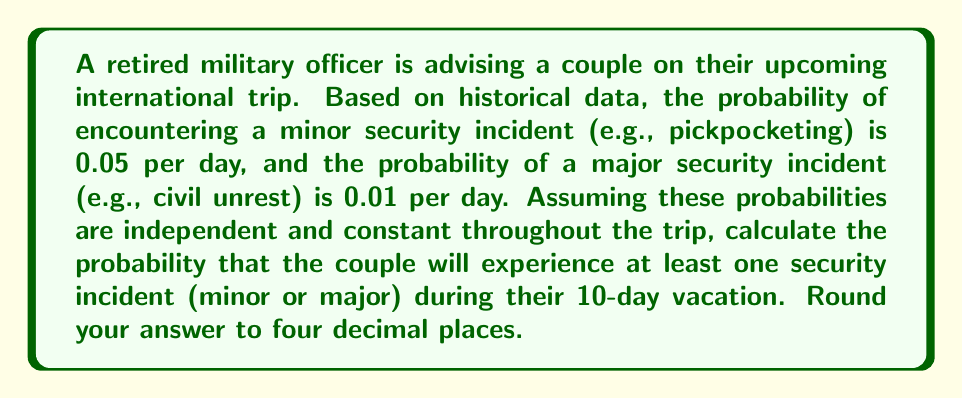Show me your answer to this math problem. Let's approach this step-by-step using probability theory:

1) First, let's calculate the probability of no incidents occurring on a single day:
   $P(\text{no incident}) = (1 - 0.05) \times (1 - 0.01) = 0.95 \times 0.99 = 0.9405$

2) For the entire 10-day trip, the probability of no incidents occurring is:
   $P(\text{no incident for 10 days}) = (0.9405)^{10}$

3) We can calculate this using logarithms:
   $\log(P(\text{no incident for 10 days})) = 10 \times \log(0.9405)$
   $= 10 \times (-0.0266) = -0.266$
   $P(\text{no incident for 10 days}) = 10^{-0.266} \approx 0.5421$

4) The probability of at least one incident occurring is the complement of this:
   $P(\text{at least one incident}) = 1 - P(\text{no incident for 10 days})$
   $= 1 - 0.5421 = 0.4579$

5) Rounding to four decimal places:
   $P(\text{at least one incident}) \approx 0.4579$
Answer: 0.4579 